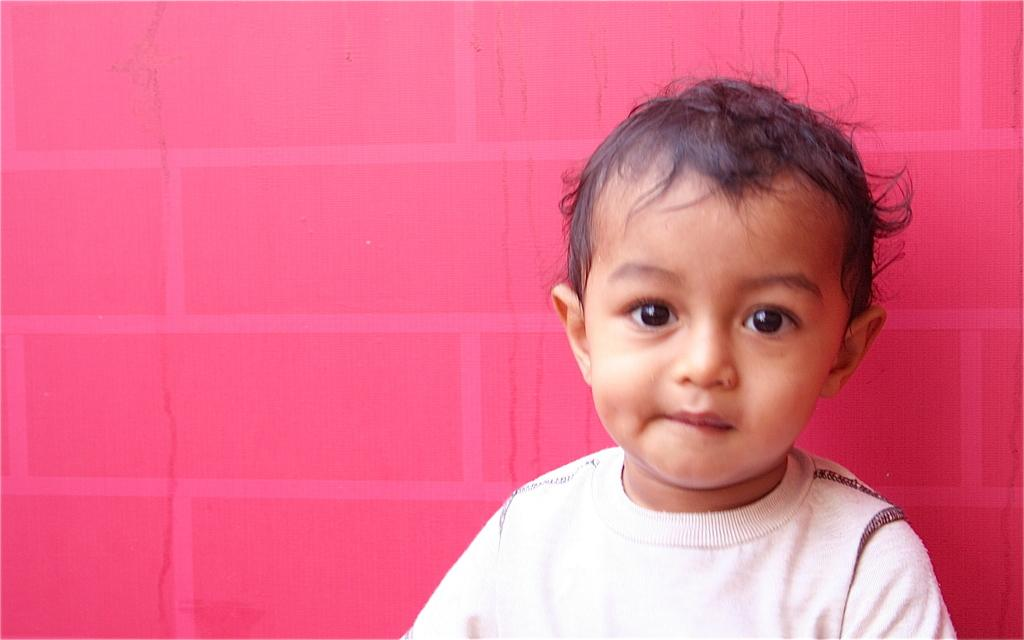Who is the main subject in the picture? There is a boy in the picture. What is the boy wearing? The boy is wearing a white t-shirt. What can be seen in the background of the picture? There is a red wall in the background of the picture. What is the boy's income in the picture? There is no information about the boy's income in the picture, as it is not relevant to the image. 